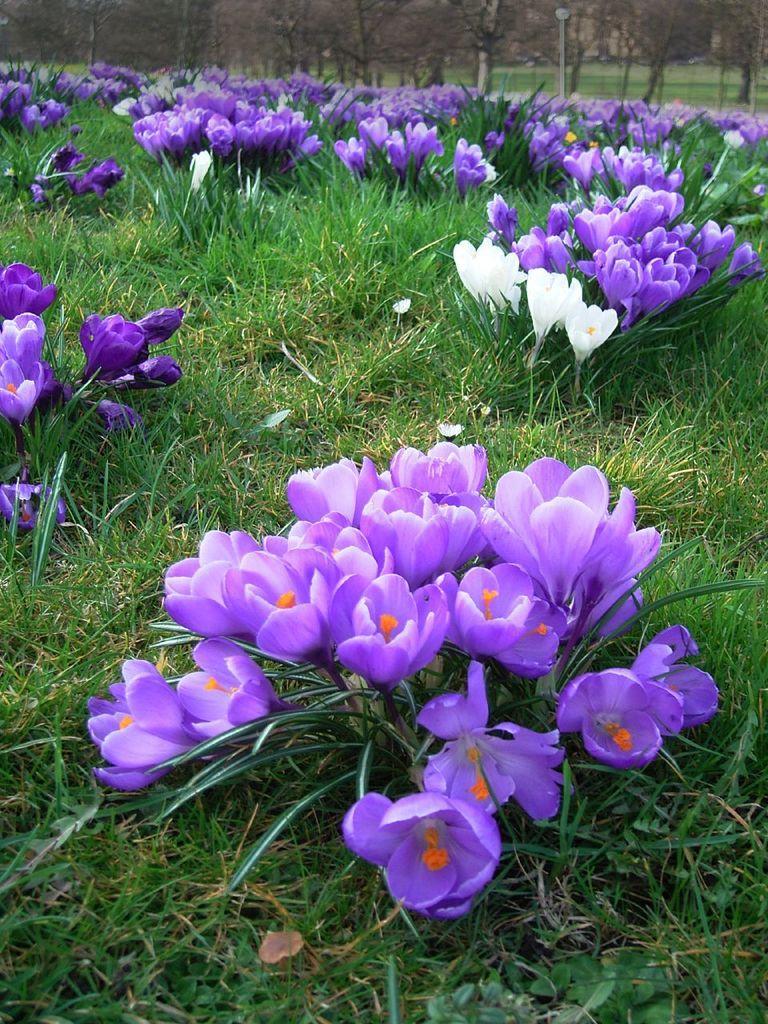Can you describe this image briefly? In this image we can see some plants with bunch of flowers. We can also see some grass, a pole and a group of trees. 